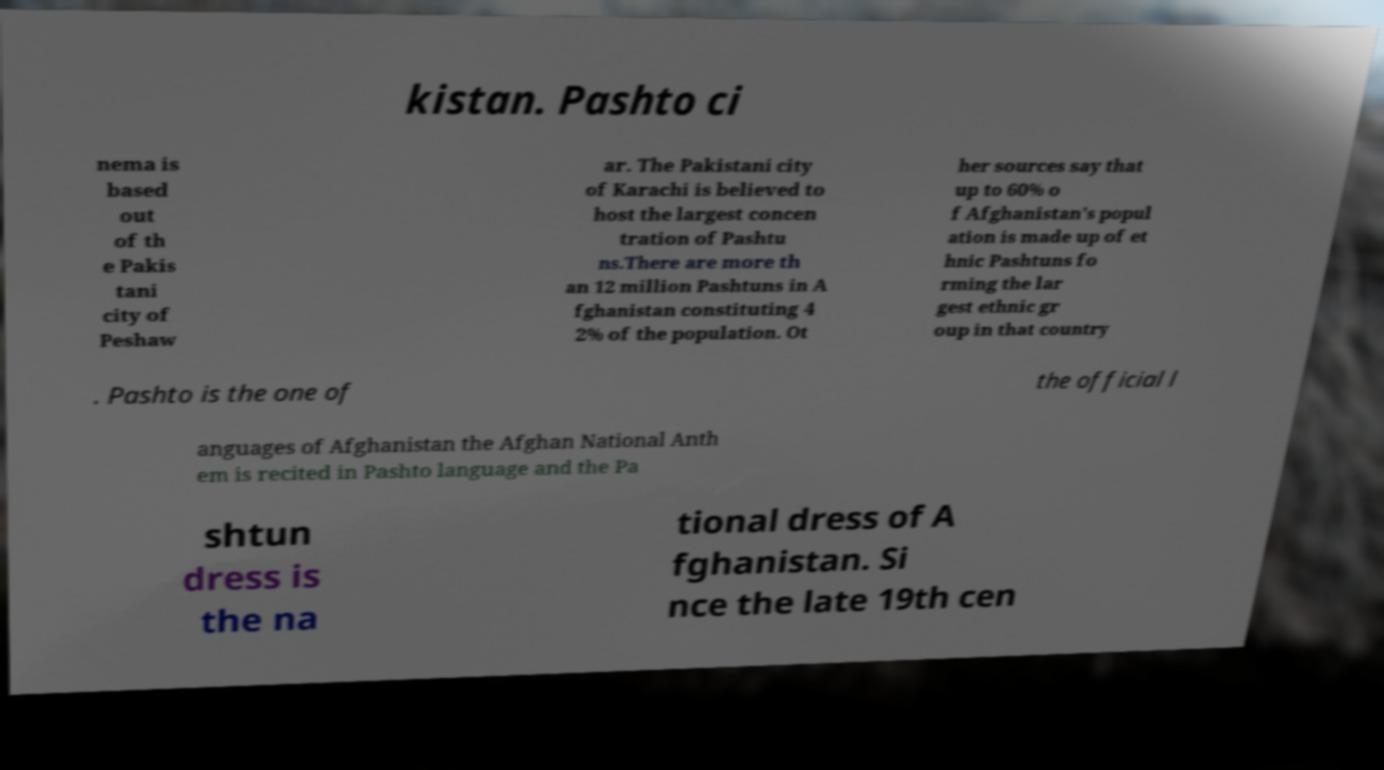Please read and relay the text visible in this image. What does it say? kistan. Pashto ci nema is based out of th e Pakis tani city of Peshaw ar. The Pakistani city of Karachi is believed to host the largest concen tration of Pashtu ns.There are more th an 12 million Pashtuns in A fghanistan constituting 4 2% of the population. Ot her sources say that up to 60% o f Afghanistan's popul ation is made up of et hnic Pashtuns fo rming the lar gest ethnic gr oup in that country . Pashto is the one of the official l anguages of Afghanistan the Afghan National Anth em is recited in Pashto language and the Pa shtun dress is the na tional dress of A fghanistan. Si nce the late 19th cen 